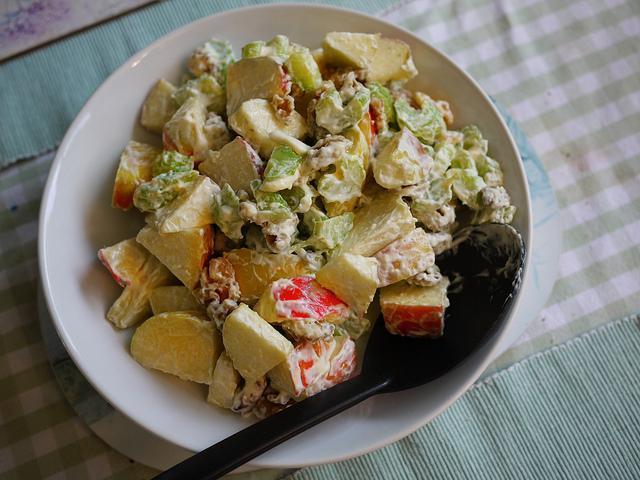What type of utensil is in the bowl?
Choose the correct response, then elucidate: 'Answer: answer
Rationale: rationale.'
Options: Scissor, spoon, knife, fork. Answer: spoon.
Rationale: A black utensil that is curved is in a bowl. you can use it to pick up items easy because things can be scooped with it. 